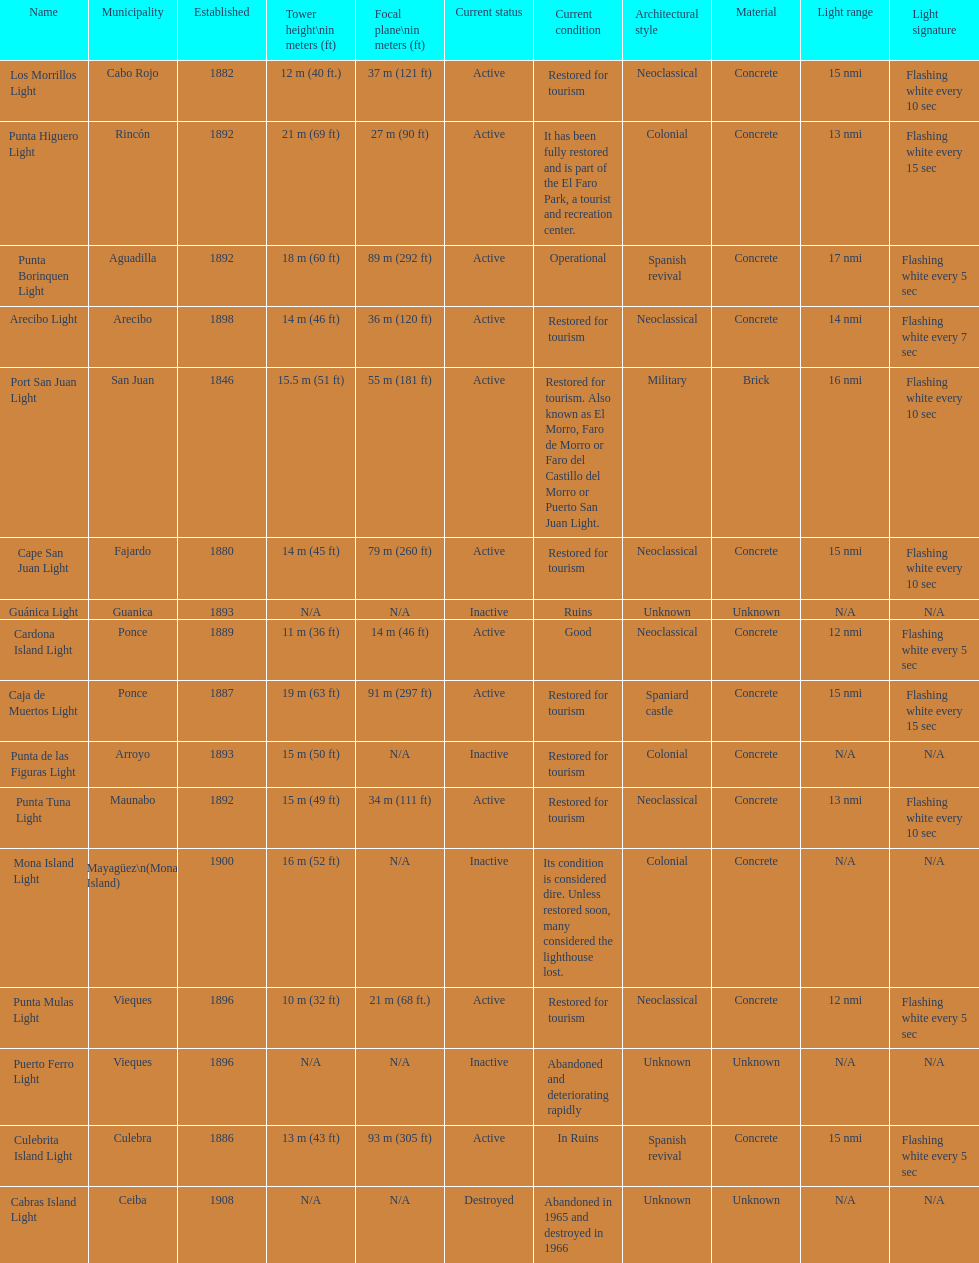The difference in years from 1882 to 1889 7. 